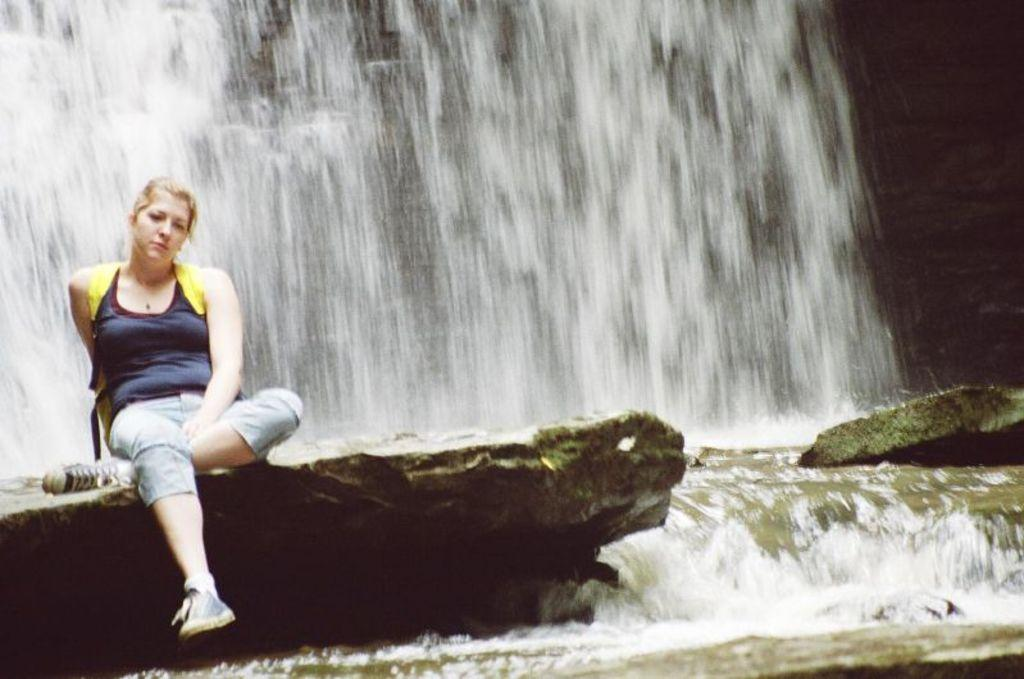What is the woman doing in the image? The woman is sitting on a rock in the image. What can be seen in the background of the image? There is a waterfall in the background of the image. What is happening with the water in the image? Water is flowing in the image. What type of waste is being disposed of in the image? There is no waste present in the image; it features a woman sitting on a rock with a waterfall in the background. 